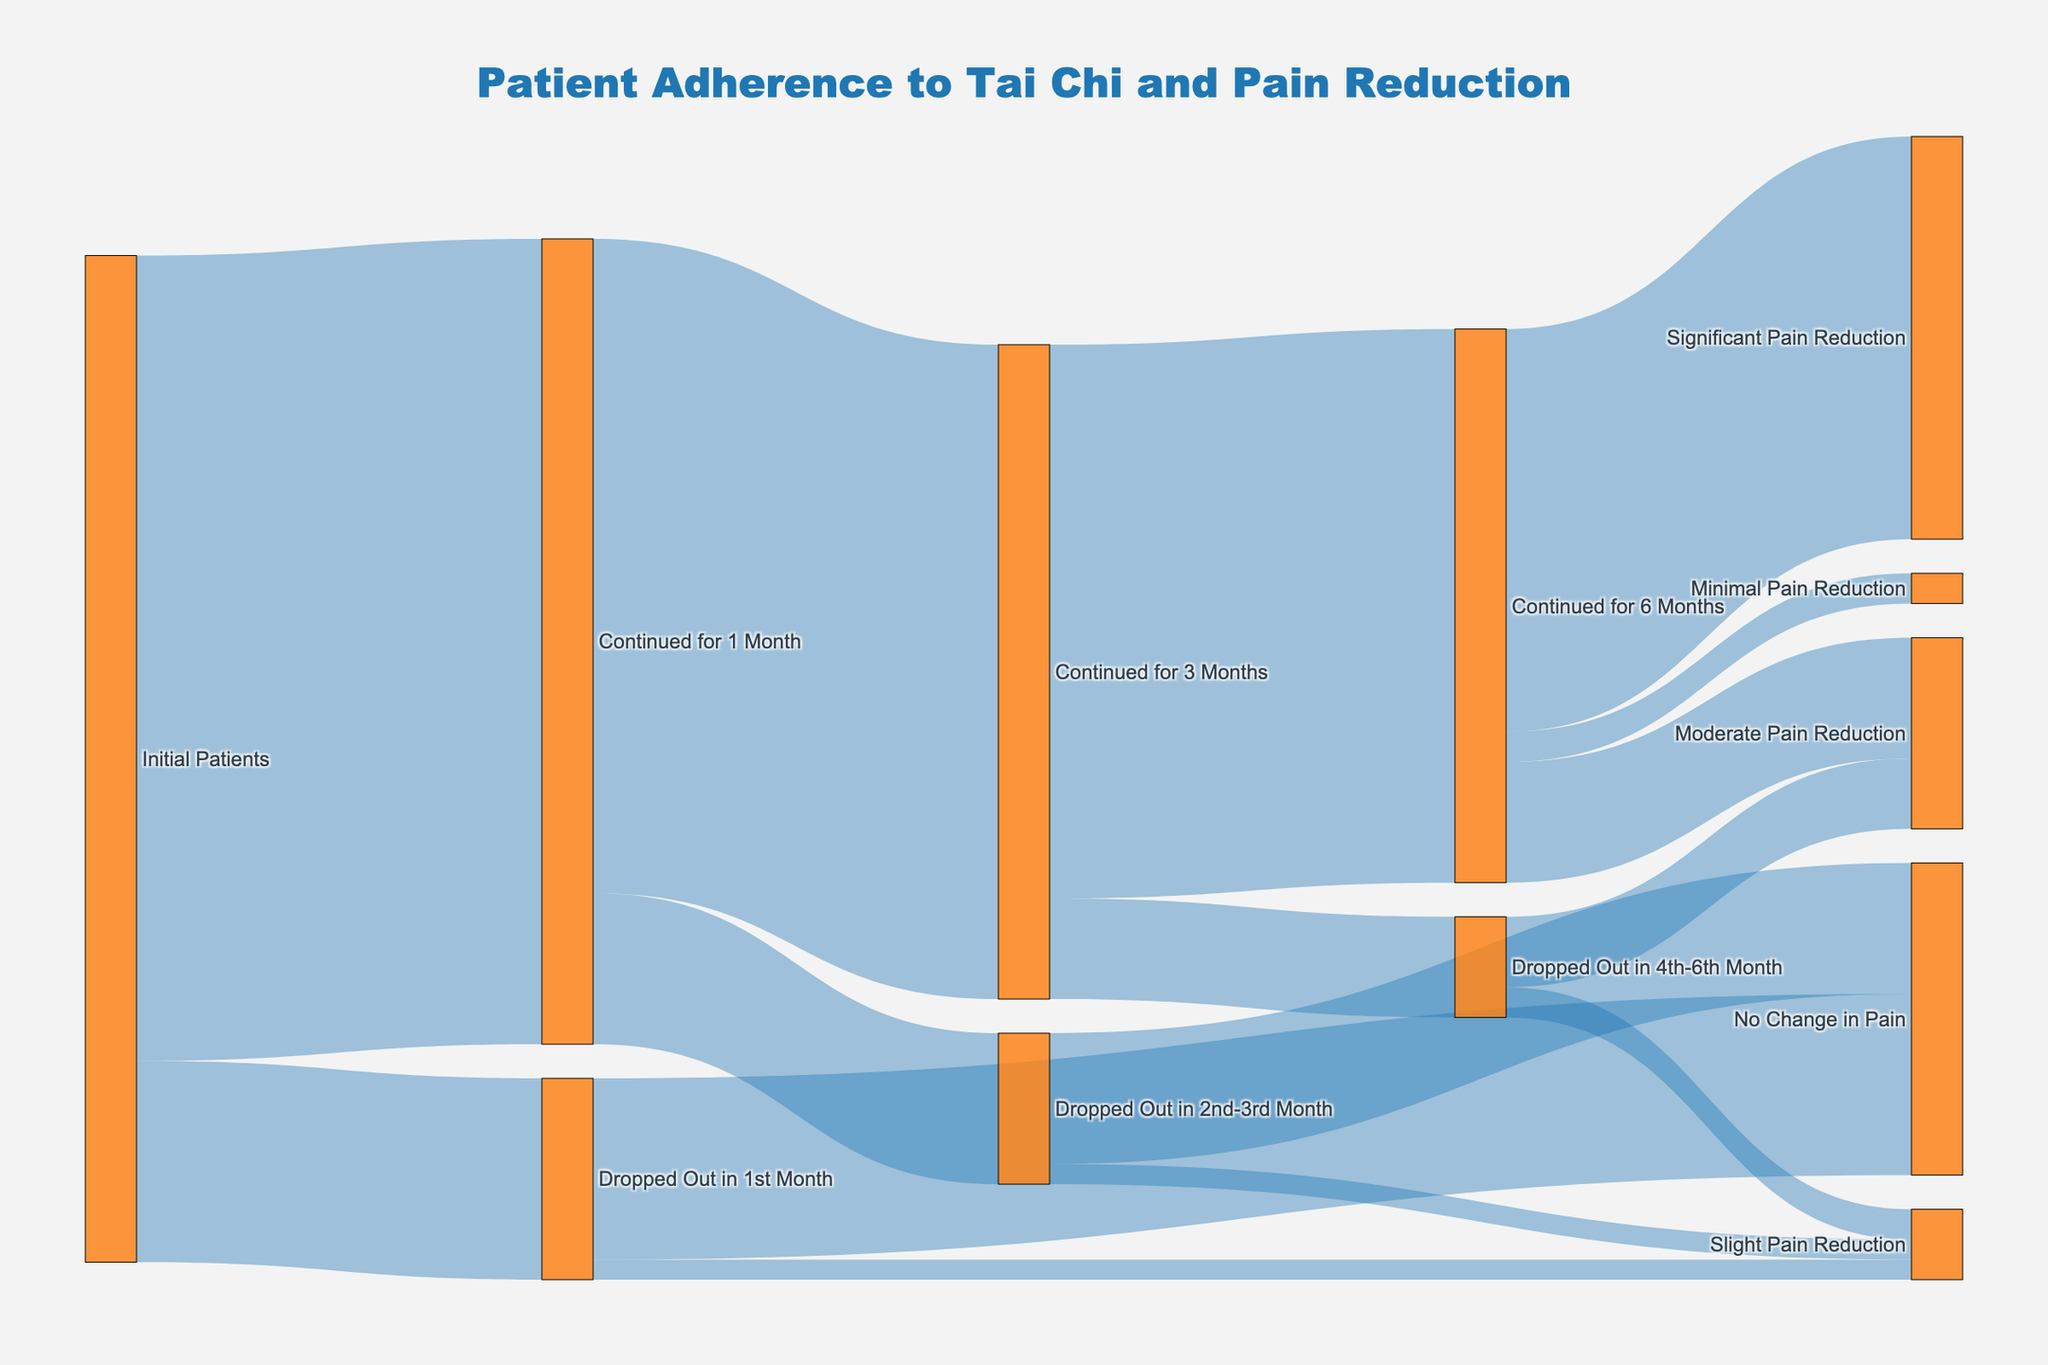What is the title of the Sankey diagram? The title is prominently displayed at the top center of the figure.
Answer: Patient Adherence to Tai Chi and Pain Reduction How many patients initially continued Tai Chi practice for 1 month? To find this, look at the flow from "Initial Patients" to "Continued for 1 Month".
Answer: 80 What was the number of patients who experienced significant pain reduction after 6 months? Trace the flow from "Continued for 6 Months" to "Significant Pain Reduction".
Answer: 40 What is the total number of patients who dropped out in the first 3 months? Sum the patients who "Dropped Out in 1st Month" and "Dropped Out in 2nd-3rd Month": 20 + 15.
Answer: 35 How many patients had no change in pain after dropping out in the first month? Look for the flow from "Dropped Out in 1st Month" to "No Change in Pain".
Answer: 18 Compare the number of patients who experienced minimal pain reduction to those who experienced moderate pain reduction after 6 months. Which group is larger? Compare the values for "Minimal Pain Reduction" and "Moderate Pain Reduction": 3 vs 12.
Answer: Moderate Pain Reduction How many patients who continued Tai Chi for 3 months, dropped out in the following (4th-6th) months? Look at the flow from "Continued for 3 Months" to "Dropped Out in 4th-6th Month".
Answer: 10 Compare the total number of patients who continued for 6 months to those who dropped out in between (2nd-6th) months. Which group is larger? Compare "Continued for 6 Months" (55) with the sum of drop-outs in 2nd-3rd months (15) and 4th-6th months (10). 55 vs 25.
Answer: Continued for 6 Months What percentage of initial patients experienced significant pain reduction after 6 months of Tai Chi? First, find the number of patients who experienced significant pain reduction (40). Divide by the total initial patients (100) and multiply by 100: (40/100) * 100%.
Answer: 40% Among those who dropped out in the 4th-6th months, how many experienced some form of pain reduction (either slight or moderate)? Sum the values "Moderate Pain Reduction" and "Slight Pain Reduction" among drop-outs in this period: 7 (Moderate) + 3 (Slight).
Answer: 10 